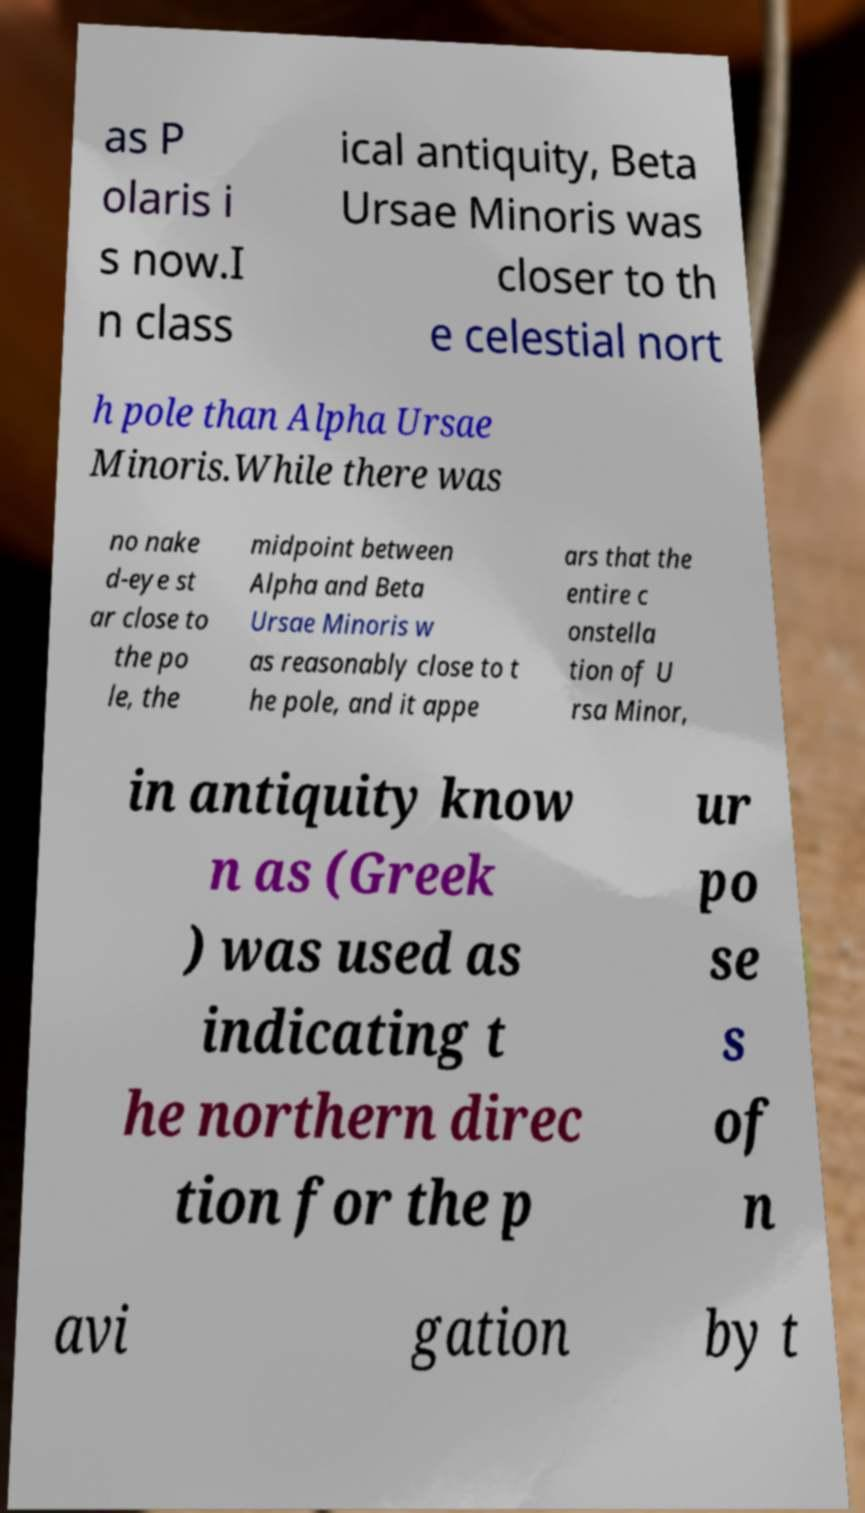What messages or text are displayed in this image? I need them in a readable, typed format. as P olaris i s now.I n class ical antiquity, Beta Ursae Minoris was closer to th e celestial nort h pole than Alpha Ursae Minoris.While there was no nake d-eye st ar close to the po le, the midpoint between Alpha and Beta Ursae Minoris w as reasonably close to t he pole, and it appe ars that the entire c onstella tion of U rsa Minor, in antiquity know n as (Greek ) was used as indicating t he northern direc tion for the p ur po se s of n avi gation by t 